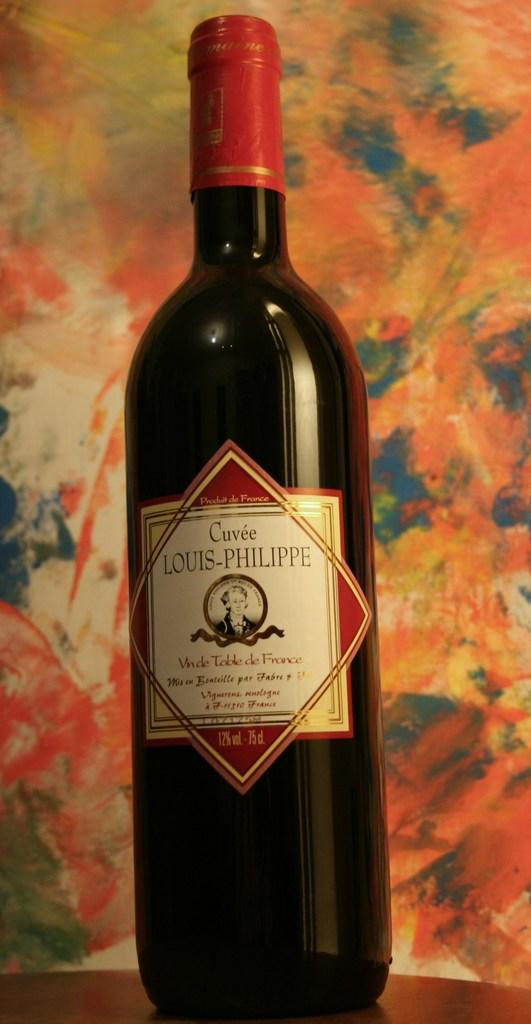<image>
Provide a brief description of the given image. A bottle of Louis Philippe wine is in front of a colorful background. 